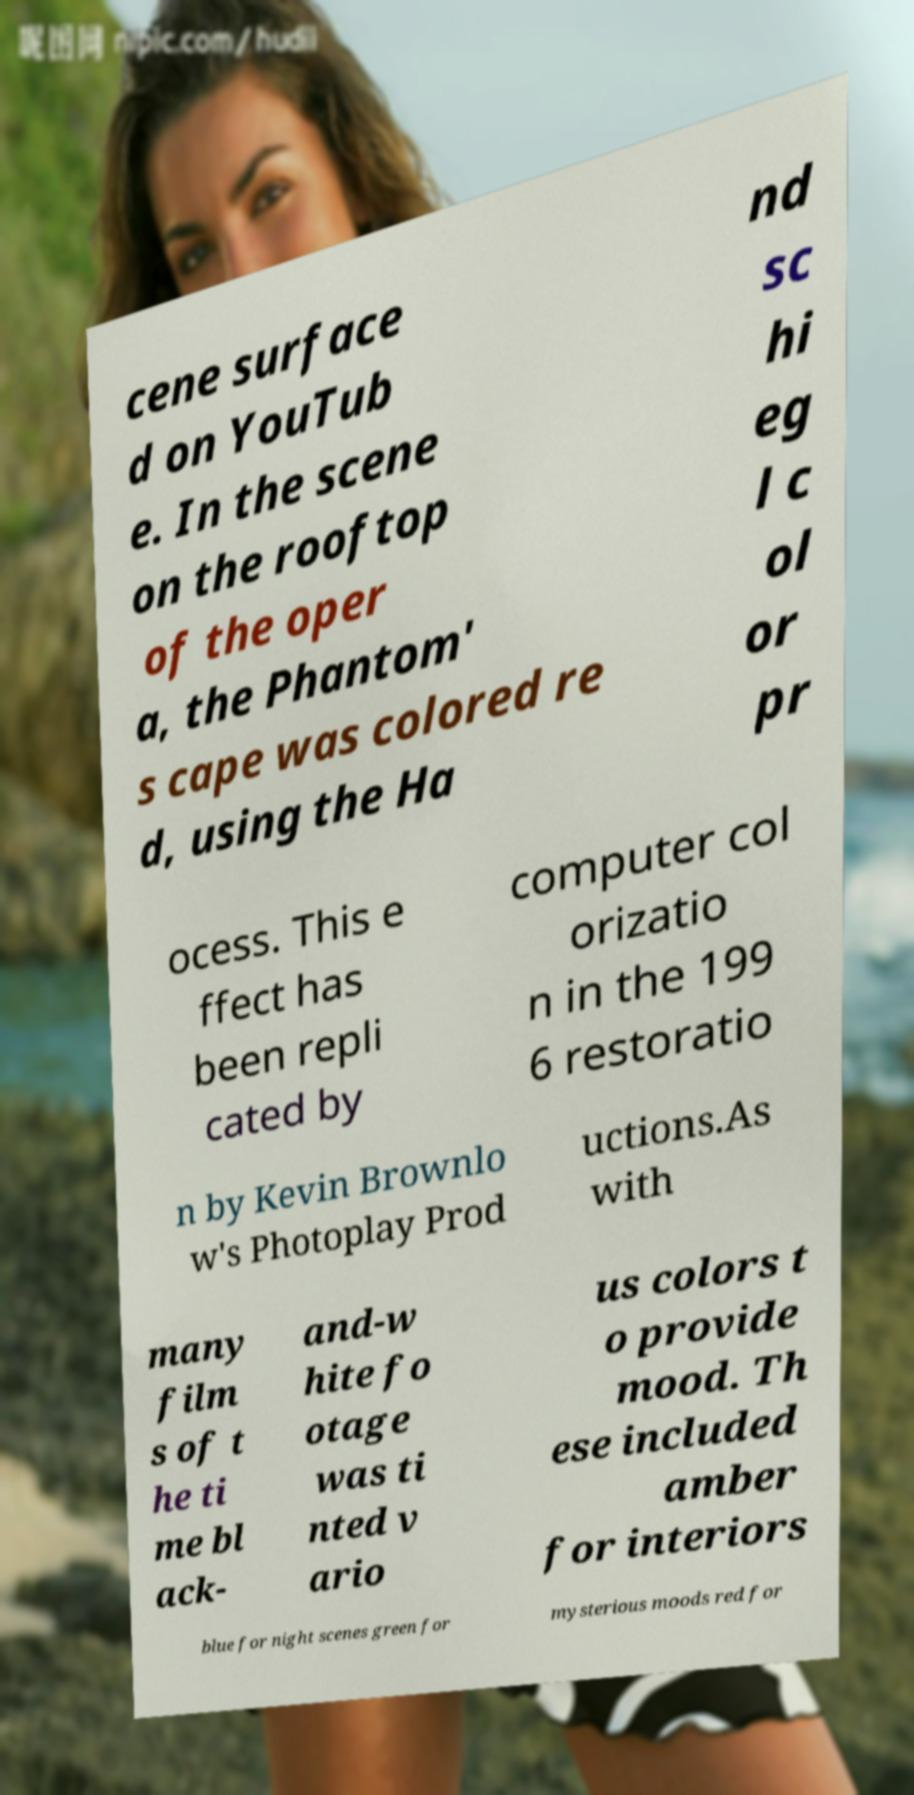I need the written content from this picture converted into text. Can you do that? cene surface d on YouTub e. In the scene on the rooftop of the oper a, the Phantom' s cape was colored re d, using the Ha nd sc hi eg l c ol or pr ocess. This e ffect has been repli cated by computer col orizatio n in the 199 6 restoratio n by Kevin Brownlo w's Photoplay Prod uctions.As with many film s of t he ti me bl ack- and-w hite fo otage was ti nted v ario us colors t o provide mood. Th ese included amber for interiors blue for night scenes green for mysterious moods red for 